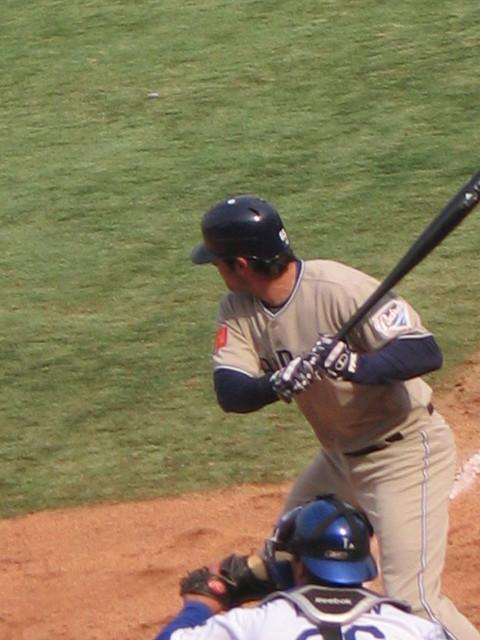What action is the man wearing blue hat doing?

Choices:
A) crouching
B) sitting
C) standing
D) kneeling crouching 